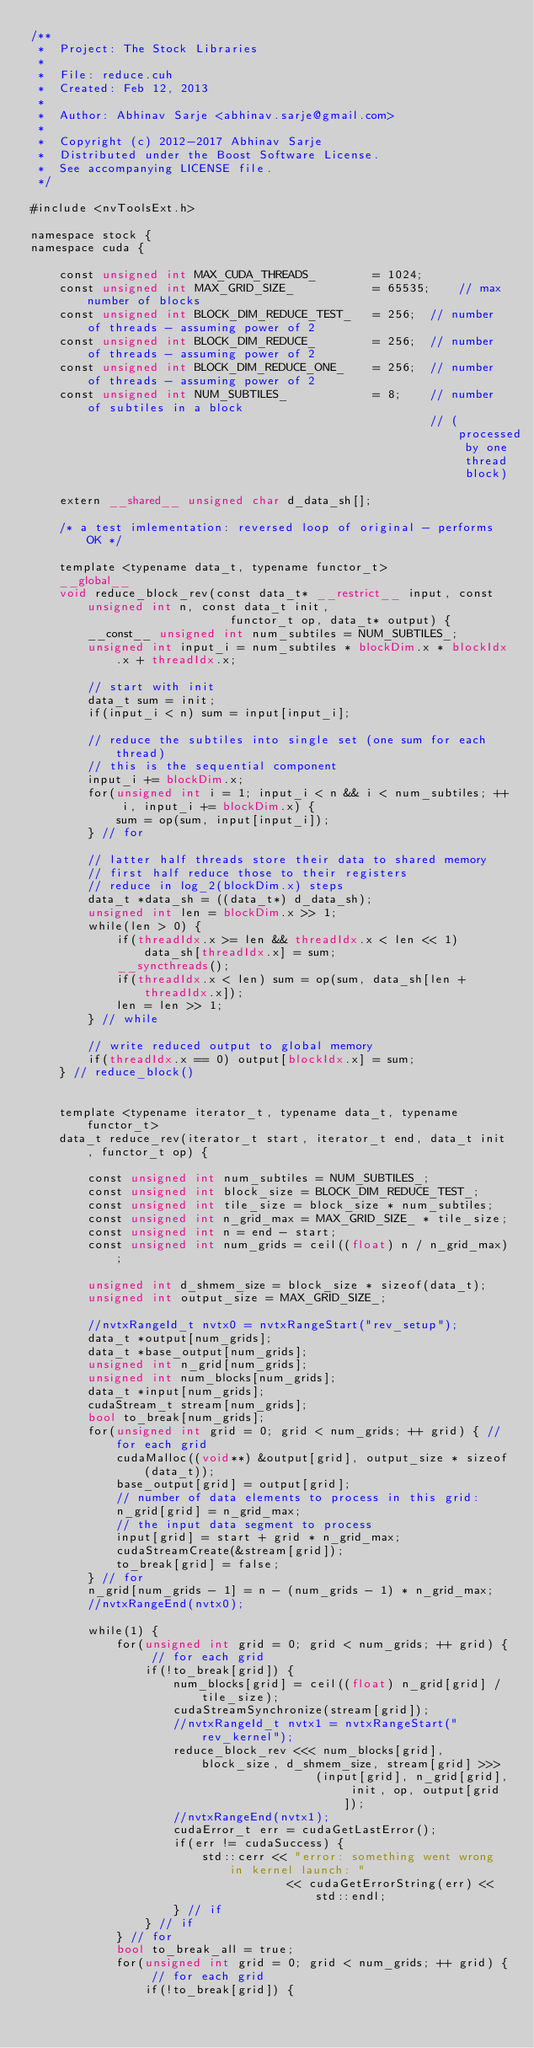<code> <loc_0><loc_0><loc_500><loc_500><_Cuda_>/**
 *  Project: The Stock Libraries
 *
 *  File: reduce.cuh
 *  Created: Feb 12, 2013
 *
 *  Author: Abhinav Sarje <abhinav.sarje@gmail.com>
 *
 *  Copyright (c) 2012-2017 Abhinav Sarje
 *  Distributed under the Boost Software License.
 *  See accompanying LICENSE file.
 */

#include <nvToolsExt.h>

namespace stock {
namespace cuda {

	const unsigned int MAX_CUDA_THREADS_		= 1024;
	const unsigned int MAX_GRID_SIZE_			= 65535;	// max number of blocks
	const unsigned int BLOCK_DIM_REDUCE_TEST_	= 256;	// number of threads - assuming power of 2
	const unsigned int BLOCK_DIM_REDUCE_		= 256;	// number of threads - assuming power of 2
	const unsigned int BLOCK_DIM_REDUCE_ONE_	= 256;	// number of threads - assuming power of 2
	const unsigned int NUM_SUBTILES_			= 8;	// number of subtiles in a block
														// (processed by one thread block)

	extern __shared__ unsigned char d_data_sh[];

	/* a test imlementation: reversed loop of original - performs OK */

	template <typename data_t, typename functor_t>
	__global__
	void reduce_block_rev(const data_t* __restrict__ input, const unsigned int n, const data_t init,
							functor_t op, data_t* output) {
		__const__ unsigned int num_subtiles = NUM_SUBTILES_;
		unsigned int input_i = num_subtiles * blockDim.x * blockIdx.x + threadIdx.x;

		// start with init
		data_t sum = init;
		if(input_i < n) sum = input[input_i];

		// reduce the subtiles into single set (one sum for each thread)
		// this is the sequential component
		input_i += blockDim.x;
		for(unsigned int i = 1; input_i < n && i < num_subtiles; ++ i, input_i += blockDim.x) {
			sum = op(sum, input[input_i]);
		} // for
		
		// latter half threads store their data to shared memory
		// first half reduce those to their registers
		// reduce in log_2(blockDim.x) steps
		data_t *data_sh = ((data_t*) d_data_sh);
		unsigned int len = blockDim.x >> 1;
		while(len > 0) {
			if(threadIdx.x >= len && threadIdx.x < len << 1) data_sh[threadIdx.x] = sum;
			__syncthreads();
			if(threadIdx.x < len) sum = op(sum, data_sh[len + threadIdx.x]);
			len = len >> 1;
		} // while

		// write reduced output to global memory
		if(threadIdx.x == 0) output[blockIdx.x] = sum;
	} // reduce_block()


	template <typename iterator_t, typename data_t, typename functor_t>
	data_t reduce_rev(iterator_t start, iterator_t end, data_t init, functor_t op) {

		const unsigned int num_subtiles = NUM_SUBTILES_;
		const unsigned int block_size = BLOCK_DIM_REDUCE_TEST_;
		const unsigned int tile_size = block_size * num_subtiles;
		const unsigned int n_grid_max = MAX_GRID_SIZE_ * tile_size;
		const unsigned int n = end - start;
		const unsigned int num_grids = ceil((float) n / n_grid_max);

		unsigned int d_shmem_size = block_size * sizeof(data_t);
		unsigned int output_size = MAX_GRID_SIZE_;

		//nvtxRangeId_t nvtx0 = nvtxRangeStart("rev_setup");
		data_t *output[num_grids];
		data_t *base_output[num_grids];
		unsigned int n_grid[num_grids];
		unsigned int num_blocks[num_grids];
		data_t *input[num_grids];
		cudaStream_t stream[num_grids];
		bool to_break[num_grids];
		for(unsigned int grid = 0; grid < num_grids; ++ grid) {	// for each grid
			cudaMalloc((void**) &output[grid], output_size * sizeof(data_t));
			base_output[grid] = output[grid];
			// number of data elements to process in this grid:
			n_grid[grid] = n_grid_max;
			// the input data segment to process
			input[grid] = start + grid * n_grid_max;
			cudaStreamCreate(&stream[grid]);
			to_break[grid] = false;
		} // for
		n_grid[num_grids - 1] = n - (num_grids - 1) * n_grid_max;
		//nvtxRangeEnd(nvtx0);

		while(1) {
			for(unsigned int grid = 0; grid < num_grids; ++ grid) {	// for each grid
				if(!to_break[grid]) {
					num_blocks[grid] = ceil((float) n_grid[grid] / tile_size);
					cudaStreamSynchronize(stream[grid]);
					//nvtxRangeId_t nvtx1 = nvtxRangeStart("rev_kernel");
					reduce_block_rev <<< num_blocks[grid], block_size, d_shmem_size, stream[grid] >>>
										(input[grid], n_grid[grid], init, op, output[grid]);
					//nvtxRangeEnd(nvtx1);
					cudaError_t err = cudaGetLastError();
					if(err != cudaSuccess) {
						std::cerr << "error: something went wrong in kernel launch: "
									<< cudaGetErrorString(err) << std::endl;
					} // if
				} // if
			} // for
			bool to_break_all = true;
			for(unsigned int grid = 0; grid < num_grids; ++ grid) {	// for each grid
				if(!to_break[grid]) {</code> 